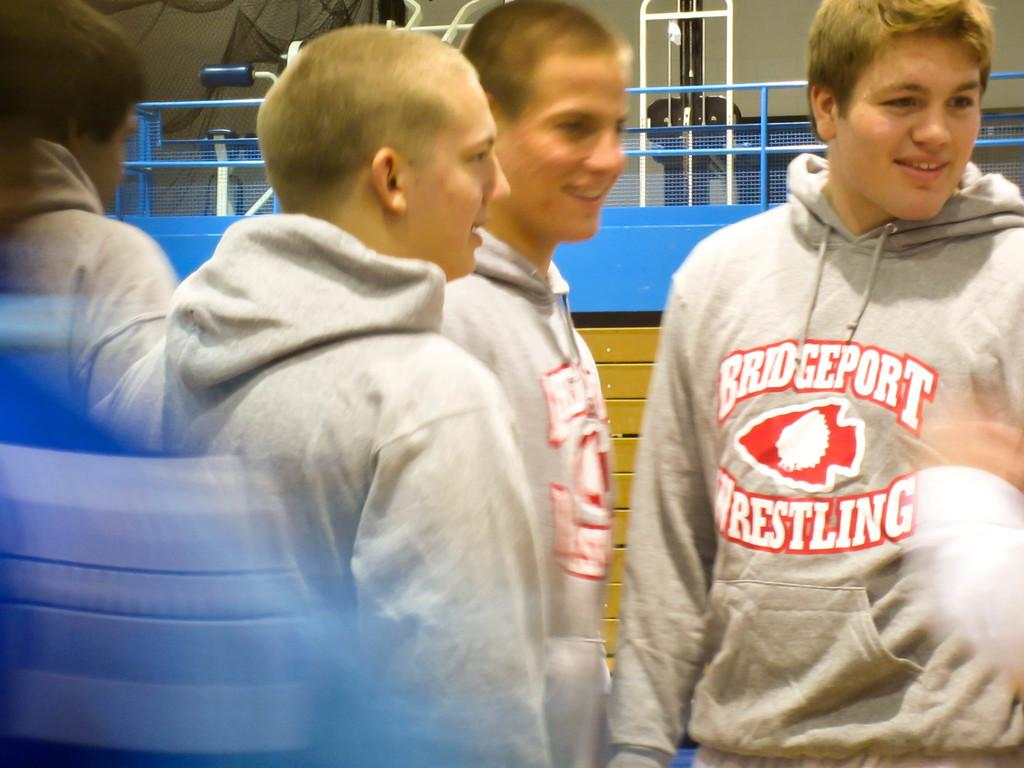<image>
Write a terse but informative summary of the picture. Three boys wearing a Bridgeport Wrestling shirt for their school. 